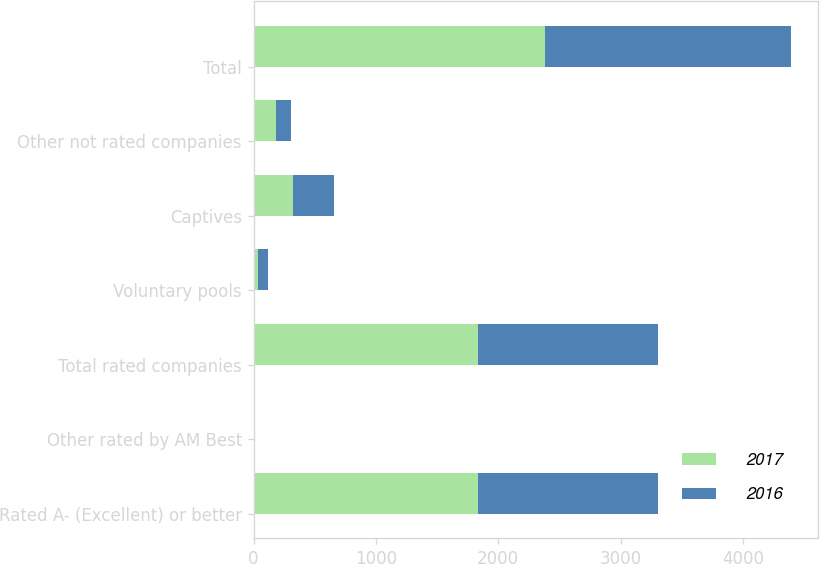Convert chart. <chart><loc_0><loc_0><loc_500><loc_500><stacked_bar_chart><ecel><fcel>Rated A- (Excellent) or better<fcel>Other rated by AM Best<fcel>Total rated companies<fcel>Voluntary pools<fcel>Captives<fcel>Other not rated companies<fcel>Total<nl><fcel>2017<fcel>1836<fcel>1<fcel>1837<fcel>37<fcel>323<fcel>184<fcel>2381<nl><fcel>2016<fcel>1470<fcel>1<fcel>1471<fcel>79<fcel>336<fcel>124<fcel>2010<nl></chart> 